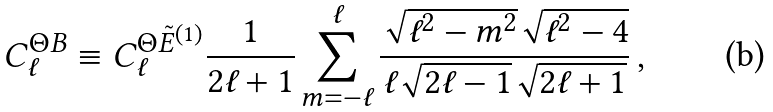Convert formula to latex. <formula><loc_0><loc_0><loc_500><loc_500>C _ { \ell } ^ { \Theta B } \equiv C _ { \ell } ^ { \Theta \tilde { E } ^ { ( 1 ) } } \frac { 1 } { 2 \ell + 1 } \sum _ { m = - \ell } ^ { \ell } \frac { \sqrt { \ell ^ { 2 } - m ^ { 2 } } \sqrt { \ell ^ { 2 } - 4 } } { \ell \sqrt { 2 \ell - 1 } \sqrt { 2 \ell + 1 } } \, ,</formula> 